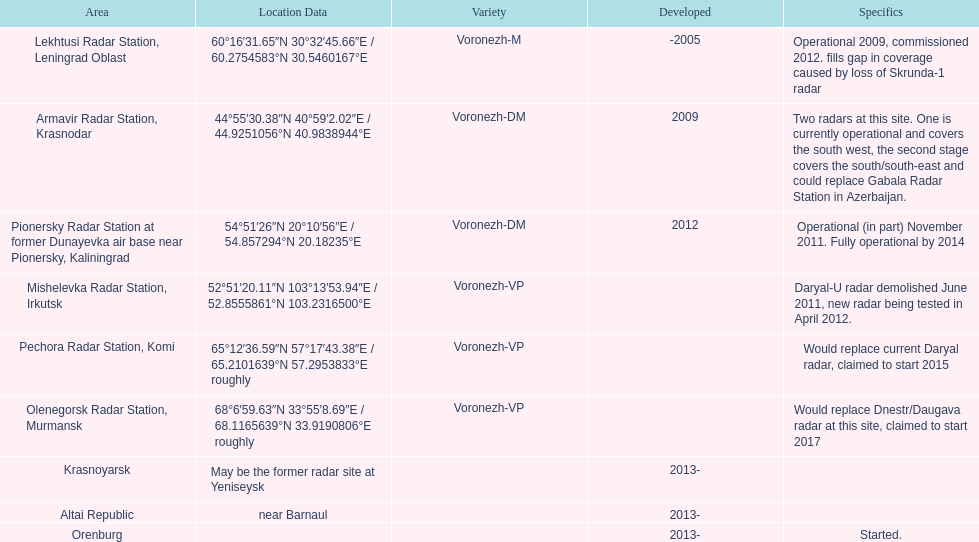What year built is at the top? -2005. Can you parse all the data within this table? {'header': ['Area', 'Location Data', 'Variety', 'Developed', 'Specifics'], 'rows': [['Lekhtusi Radar Station, Leningrad Oblast', '60°16′31.65″N 30°32′45.66″E\ufeff / \ufeff60.2754583°N 30.5460167°E', 'Voronezh-M', '-2005', 'Operational 2009, commissioned 2012. fills gap in coverage caused by loss of Skrunda-1 radar'], ['Armavir Radar Station, Krasnodar', '44°55′30.38″N 40°59′2.02″E\ufeff / \ufeff44.9251056°N 40.9838944°E', 'Voronezh-DM', '2009', 'Two radars at this site. One is currently operational and covers the south west, the second stage covers the south/south-east and could replace Gabala Radar Station in Azerbaijan.'], ['Pionersky Radar Station at former Dunayevka air base near Pionersky, Kaliningrad', '54°51′26″N 20°10′56″E\ufeff / \ufeff54.857294°N 20.18235°E', 'Voronezh-DM', '2012', 'Operational (in part) November 2011. Fully operational by 2014'], ['Mishelevka Radar Station, Irkutsk', '52°51′20.11″N 103°13′53.94″E\ufeff / \ufeff52.8555861°N 103.2316500°E', 'Voronezh-VP', '', 'Daryal-U radar demolished June 2011, new radar being tested in April 2012.'], ['Pechora Radar Station, Komi', '65°12′36.59″N 57°17′43.38″E\ufeff / \ufeff65.2101639°N 57.2953833°E roughly', 'Voronezh-VP', '', 'Would replace current Daryal radar, claimed to start 2015'], ['Olenegorsk Radar Station, Murmansk', '68°6′59.63″N 33°55′8.69″E\ufeff / \ufeff68.1165639°N 33.9190806°E roughly', 'Voronezh-VP', '', 'Would replace Dnestr/Daugava radar at this site, claimed to start 2017'], ['Krasnoyarsk', 'May be the former radar site at Yeniseysk', '', '2013-', ''], ['Altai Republic', 'near Barnaul', '', '2013-', ''], ['Orenburg', '', '', '2013-', 'Started.']]} 